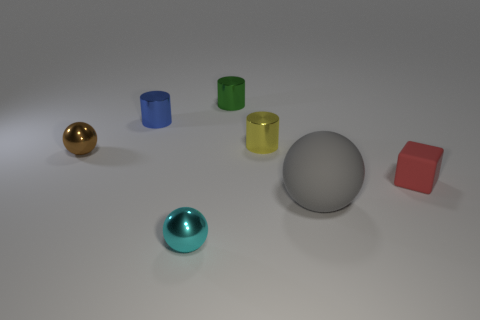Add 2 large gray things. How many objects exist? 9 Subtract all small spheres. How many spheres are left? 1 Subtract 1 cylinders. How many cylinders are left? 2 Subtract all cylinders. How many objects are left? 4 Subtract all blue cylinders. How many cylinders are left? 2 Add 5 cyan metallic cylinders. How many cyan metallic cylinders exist? 5 Subtract 1 green cylinders. How many objects are left? 6 Subtract all yellow cylinders. Subtract all yellow cubes. How many cylinders are left? 2 Subtract all brown shiny cubes. Subtract all brown things. How many objects are left? 6 Add 1 green cylinders. How many green cylinders are left? 2 